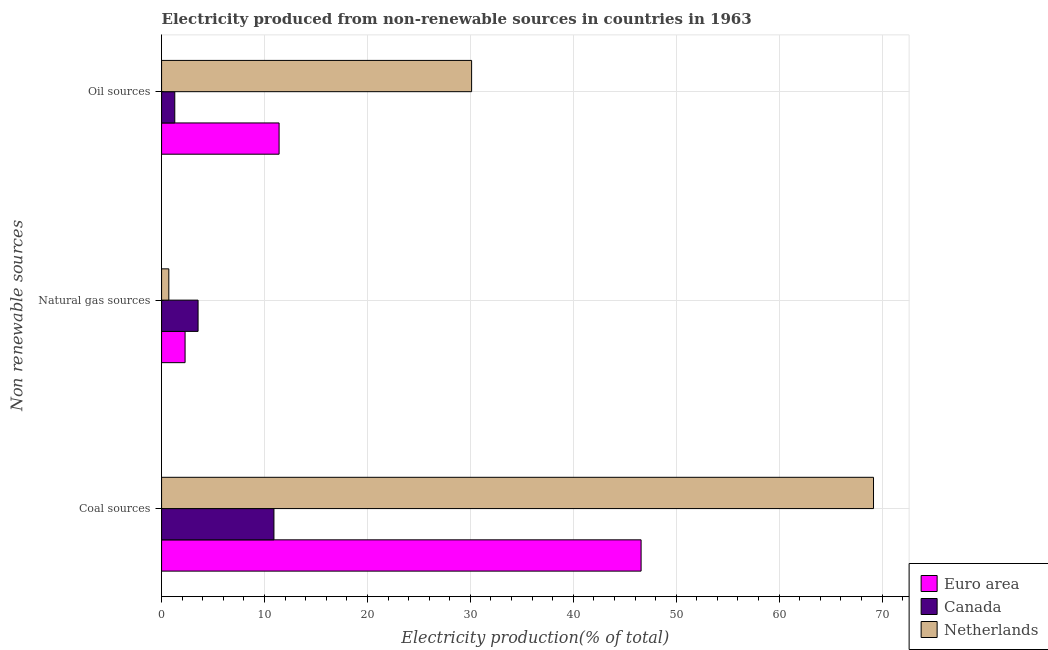Are the number of bars on each tick of the Y-axis equal?
Your response must be concise. Yes. What is the label of the 1st group of bars from the top?
Your answer should be very brief. Oil sources. What is the percentage of electricity produced by oil sources in Canada?
Provide a succinct answer. 1.28. Across all countries, what is the maximum percentage of electricity produced by oil sources?
Make the answer very short. 30.12. Across all countries, what is the minimum percentage of electricity produced by natural gas?
Offer a very short reply. 0.71. In which country was the percentage of electricity produced by oil sources maximum?
Offer a very short reply. Netherlands. What is the total percentage of electricity produced by coal in the graph?
Ensure brevity in your answer.  126.68. What is the difference between the percentage of electricity produced by coal in Canada and that in Netherlands?
Provide a short and direct response. -58.25. What is the difference between the percentage of electricity produced by natural gas in Euro area and the percentage of electricity produced by oil sources in Netherlands?
Keep it short and to the point. -27.84. What is the average percentage of electricity produced by coal per country?
Your answer should be very brief. 42.23. What is the difference between the percentage of electricity produced by oil sources and percentage of electricity produced by coal in Netherlands?
Offer a terse response. -39.05. What is the ratio of the percentage of electricity produced by natural gas in Canada to that in Netherlands?
Your answer should be very brief. 5.03. Is the percentage of electricity produced by natural gas in Euro area less than that in Canada?
Provide a succinct answer. Yes. What is the difference between the highest and the second highest percentage of electricity produced by coal?
Keep it short and to the point. 22.58. What is the difference between the highest and the lowest percentage of electricity produced by coal?
Ensure brevity in your answer.  58.25. In how many countries, is the percentage of electricity produced by coal greater than the average percentage of electricity produced by coal taken over all countries?
Offer a terse response. 2. What does the 1st bar from the bottom in Coal sources represents?
Provide a succinct answer. Euro area. Are all the bars in the graph horizontal?
Provide a short and direct response. Yes. How many countries are there in the graph?
Provide a succinct answer. 3. What is the difference between two consecutive major ticks on the X-axis?
Ensure brevity in your answer.  10. How many legend labels are there?
Offer a terse response. 3. What is the title of the graph?
Give a very brief answer. Electricity produced from non-renewable sources in countries in 1963. Does "Zimbabwe" appear as one of the legend labels in the graph?
Provide a succinct answer. No. What is the label or title of the X-axis?
Keep it short and to the point. Electricity production(% of total). What is the label or title of the Y-axis?
Provide a succinct answer. Non renewable sources. What is the Electricity production(% of total) in Euro area in Coal sources?
Your answer should be compact. 46.59. What is the Electricity production(% of total) in Canada in Coal sources?
Your answer should be very brief. 10.92. What is the Electricity production(% of total) of Netherlands in Coal sources?
Offer a terse response. 69.17. What is the Electricity production(% of total) in Euro area in Natural gas sources?
Offer a terse response. 2.28. What is the Electricity production(% of total) in Canada in Natural gas sources?
Make the answer very short. 3.55. What is the Electricity production(% of total) of Netherlands in Natural gas sources?
Give a very brief answer. 0.71. What is the Electricity production(% of total) of Euro area in Oil sources?
Keep it short and to the point. 11.42. What is the Electricity production(% of total) in Canada in Oil sources?
Keep it short and to the point. 1.28. What is the Electricity production(% of total) in Netherlands in Oil sources?
Keep it short and to the point. 30.12. Across all Non renewable sources, what is the maximum Electricity production(% of total) in Euro area?
Give a very brief answer. 46.59. Across all Non renewable sources, what is the maximum Electricity production(% of total) in Canada?
Your answer should be compact. 10.92. Across all Non renewable sources, what is the maximum Electricity production(% of total) in Netherlands?
Ensure brevity in your answer.  69.17. Across all Non renewable sources, what is the minimum Electricity production(% of total) of Euro area?
Provide a short and direct response. 2.28. Across all Non renewable sources, what is the minimum Electricity production(% of total) of Canada?
Provide a succinct answer. 1.28. Across all Non renewable sources, what is the minimum Electricity production(% of total) in Netherlands?
Offer a terse response. 0.71. What is the total Electricity production(% of total) of Euro area in the graph?
Your response must be concise. 60.29. What is the total Electricity production(% of total) in Canada in the graph?
Give a very brief answer. 15.75. What is the total Electricity production(% of total) in Netherlands in the graph?
Offer a very short reply. 100. What is the difference between the Electricity production(% of total) of Euro area in Coal sources and that in Natural gas sources?
Give a very brief answer. 44.31. What is the difference between the Electricity production(% of total) in Canada in Coal sources and that in Natural gas sources?
Provide a succinct answer. 7.37. What is the difference between the Electricity production(% of total) in Netherlands in Coal sources and that in Natural gas sources?
Make the answer very short. 68.47. What is the difference between the Electricity production(% of total) of Euro area in Coal sources and that in Oil sources?
Your answer should be compact. 35.17. What is the difference between the Electricity production(% of total) in Canada in Coal sources and that in Oil sources?
Offer a terse response. 9.63. What is the difference between the Electricity production(% of total) in Netherlands in Coal sources and that in Oil sources?
Provide a succinct answer. 39.05. What is the difference between the Electricity production(% of total) in Euro area in Natural gas sources and that in Oil sources?
Ensure brevity in your answer.  -9.13. What is the difference between the Electricity production(% of total) of Canada in Natural gas sources and that in Oil sources?
Ensure brevity in your answer.  2.26. What is the difference between the Electricity production(% of total) of Netherlands in Natural gas sources and that in Oil sources?
Offer a terse response. -29.42. What is the difference between the Electricity production(% of total) in Euro area in Coal sources and the Electricity production(% of total) in Canada in Natural gas sources?
Ensure brevity in your answer.  43.04. What is the difference between the Electricity production(% of total) of Euro area in Coal sources and the Electricity production(% of total) of Netherlands in Natural gas sources?
Provide a succinct answer. 45.88. What is the difference between the Electricity production(% of total) of Canada in Coal sources and the Electricity production(% of total) of Netherlands in Natural gas sources?
Offer a terse response. 10.21. What is the difference between the Electricity production(% of total) in Euro area in Coal sources and the Electricity production(% of total) in Canada in Oil sources?
Give a very brief answer. 45.31. What is the difference between the Electricity production(% of total) in Euro area in Coal sources and the Electricity production(% of total) in Netherlands in Oil sources?
Provide a short and direct response. 16.47. What is the difference between the Electricity production(% of total) of Canada in Coal sources and the Electricity production(% of total) of Netherlands in Oil sources?
Ensure brevity in your answer.  -19.21. What is the difference between the Electricity production(% of total) in Euro area in Natural gas sources and the Electricity production(% of total) in Netherlands in Oil sources?
Your answer should be very brief. -27.84. What is the difference between the Electricity production(% of total) of Canada in Natural gas sources and the Electricity production(% of total) of Netherlands in Oil sources?
Provide a succinct answer. -26.58. What is the average Electricity production(% of total) of Euro area per Non renewable sources?
Your response must be concise. 20.1. What is the average Electricity production(% of total) of Canada per Non renewable sources?
Offer a terse response. 5.25. What is the average Electricity production(% of total) of Netherlands per Non renewable sources?
Provide a succinct answer. 33.33. What is the difference between the Electricity production(% of total) in Euro area and Electricity production(% of total) in Canada in Coal sources?
Keep it short and to the point. 35.67. What is the difference between the Electricity production(% of total) in Euro area and Electricity production(% of total) in Netherlands in Coal sources?
Make the answer very short. -22.58. What is the difference between the Electricity production(% of total) in Canada and Electricity production(% of total) in Netherlands in Coal sources?
Give a very brief answer. -58.25. What is the difference between the Electricity production(% of total) in Euro area and Electricity production(% of total) in Canada in Natural gas sources?
Ensure brevity in your answer.  -1.26. What is the difference between the Electricity production(% of total) of Euro area and Electricity production(% of total) of Netherlands in Natural gas sources?
Provide a succinct answer. 1.58. What is the difference between the Electricity production(% of total) in Canada and Electricity production(% of total) in Netherlands in Natural gas sources?
Offer a very short reply. 2.84. What is the difference between the Electricity production(% of total) of Euro area and Electricity production(% of total) of Canada in Oil sources?
Provide a short and direct response. 10.13. What is the difference between the Electricity production(% of total) of Euro area and Electricity production(% of total) of Netherlands in Oil sources?
Make the answer very short. -18.71. What is the difference between the Electricity production(% of total) in Canada and Electricity production(% of total) in Netherlands in Oil sources?
Your answer should be very brief. -28.84. What is the ratio of the Electricity production(% of total) in Euro area in Coal sources to that in Natural gas sources?
Offer a terse response. 20.4. What is the ratio of the Electricity production(% of total) in Canada in Coal sources to that in Natural gas sources?
Keep it short and to the point. 3.08. What is the ratio of the Electricity production(% of total) of Netherlands in Coal sources to that in Natural gas sources?
Offer a very short reply. 98.07. What is the ratio of the Electricity production(% of total) of Euro area in Coal sources to that in Oil sources?
Ensure brevity in your answer.  4.08. What is the ratio of the Electricity production(% of total) of Canada in Coal sources to that in Oil sources?
Provide a short and direct response. 8.5. What is the ratio of the Electricity production(% of total) in Netherlands in Coal sources to that in Oil sources?
Your answer should be very brief. 2.3. What is the ratio of the Electricity production(% of total) in Euro area in Natural gas sources to that in Oil sources?
Offer a very short reply. 0.2. What is the ratio of the Electricity production(% of total) of Canada in Natural gas sources to that in Oil sources?
Give a very brief answer. 2.76. What is the ratio of the Electricity production(% of total) of Netherlands in Natural gas sources to that in Oil sources?
Your response must be concise. 0.02. What is the difference between the highest and the second highest Electricity production(% of total) in Euro area?
Your response must be concise. 35.17. What is the difference between the highest and the second highest Electricity production(% of total) of Canada?
Your answer should be very brief. 7.37. What is the difference between the highest and the second highest Electricity production(% of total) of Netherlands?
Keep it short and to the point. 39.05. What is the difference between the highest and the lowest Electricity production(% of total) of Euro area?
Ensure brevity in your answer.  44.31. What is the difference between the highest and the lowest Electricity production(% of total) of Canada?
Provide a succinct answer. 9.63. What is the difference between the highest and the lowest Electricity production(% of total) in Netherlands?
Your response must be concise. 68.47. 